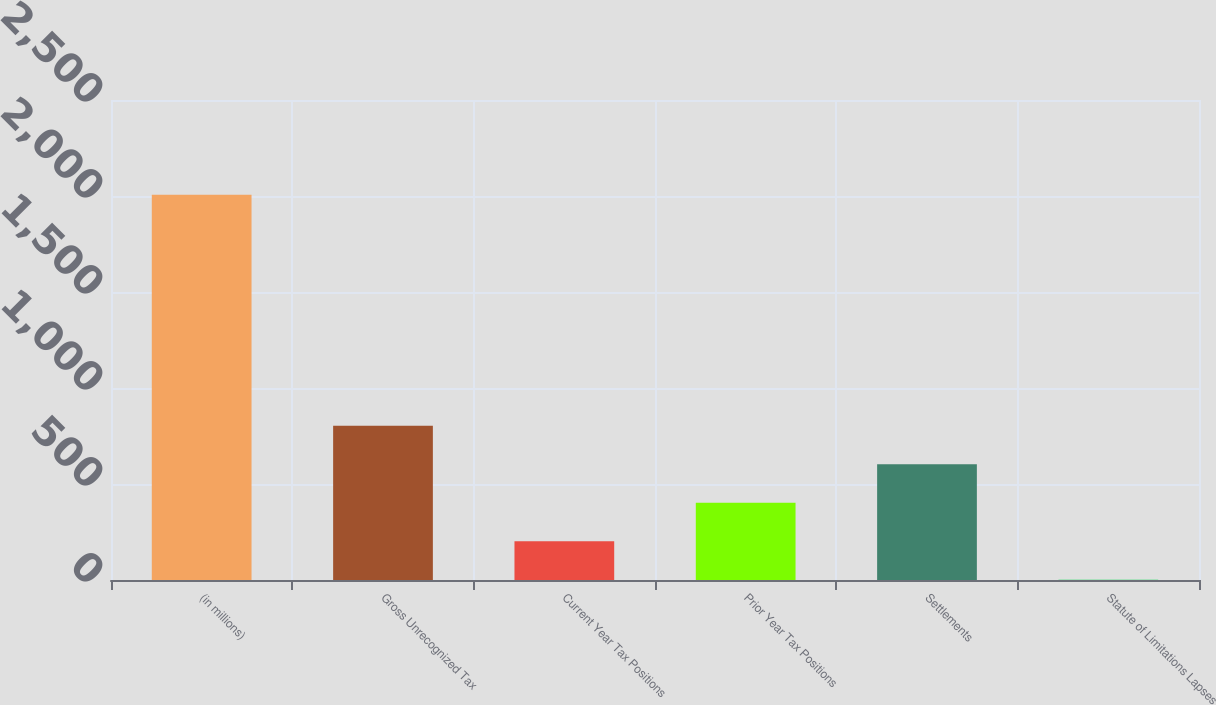<chart> <loc_0><loc_0><loc_500><loc_500><bar_chart><fcel>(in millions)<fcel>Gross Unrecognized Tax<fcel>Current Year Tax Positions<fcel>Prior Year Tax Positions<fcel>Settlements<fcel>Statute of Limitations Lapses<nl><fcel>2007<fcel>803.4<fcel>201.6<fcel>402.2<fcel>602.8<fcel>1<nl></chart> 